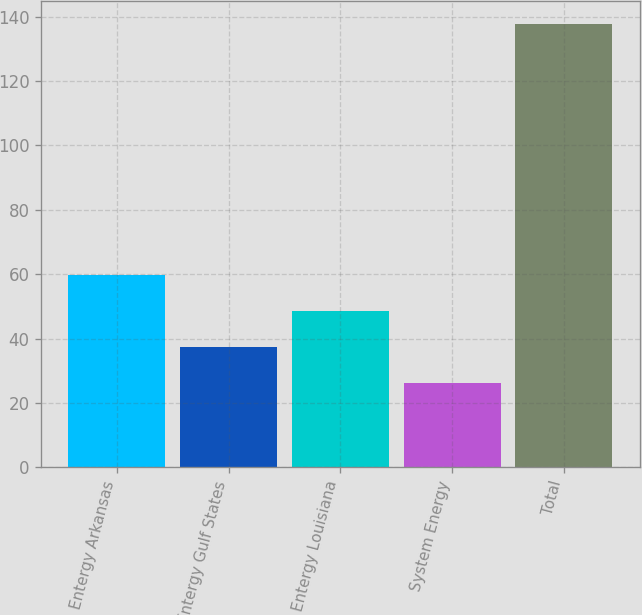Convert chart. <chart><loc_0><loc_0><loc_500><loc_500><bar_chart><fcel>Entergy Arkansas<fcel>Entergy Gulf States<fcel>Entergy Louisiana<fcel>System Energy<fcel>Total<nl><fcel>59.61<fcel>37.27<fcel>48.44<fcel>26.1<fcel>137.8<nl></chart> 